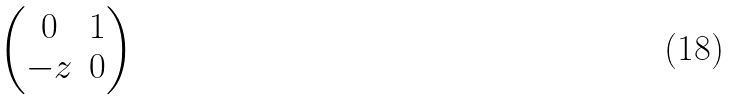<formula> <loc_0><loc_0><loc_500><loc_500>\begin{pmatrix} 0 & 1 \\ - z & 0 \end{pmatrix}</formula> 